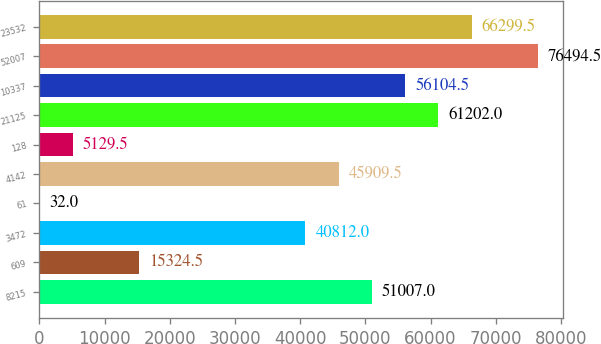Convert chart. <chart><loc_0><loc_0><loc_500><loc_500><bar_chart><fcel>8215<fcel>609<fcel>3472<fcel>61<fcel>4142<fcel>128<fcel>21125<fcel>10337<fcel>52007<fcel>23532<nl><fcel>51007<fcel>15324.5<fcel>40812<fcel>32<fcel>45909.5<fcel>5129.5<fcel>61202<fcel>56104.5<fcel>76494.5<fcel>66299.5<nl></chart> 